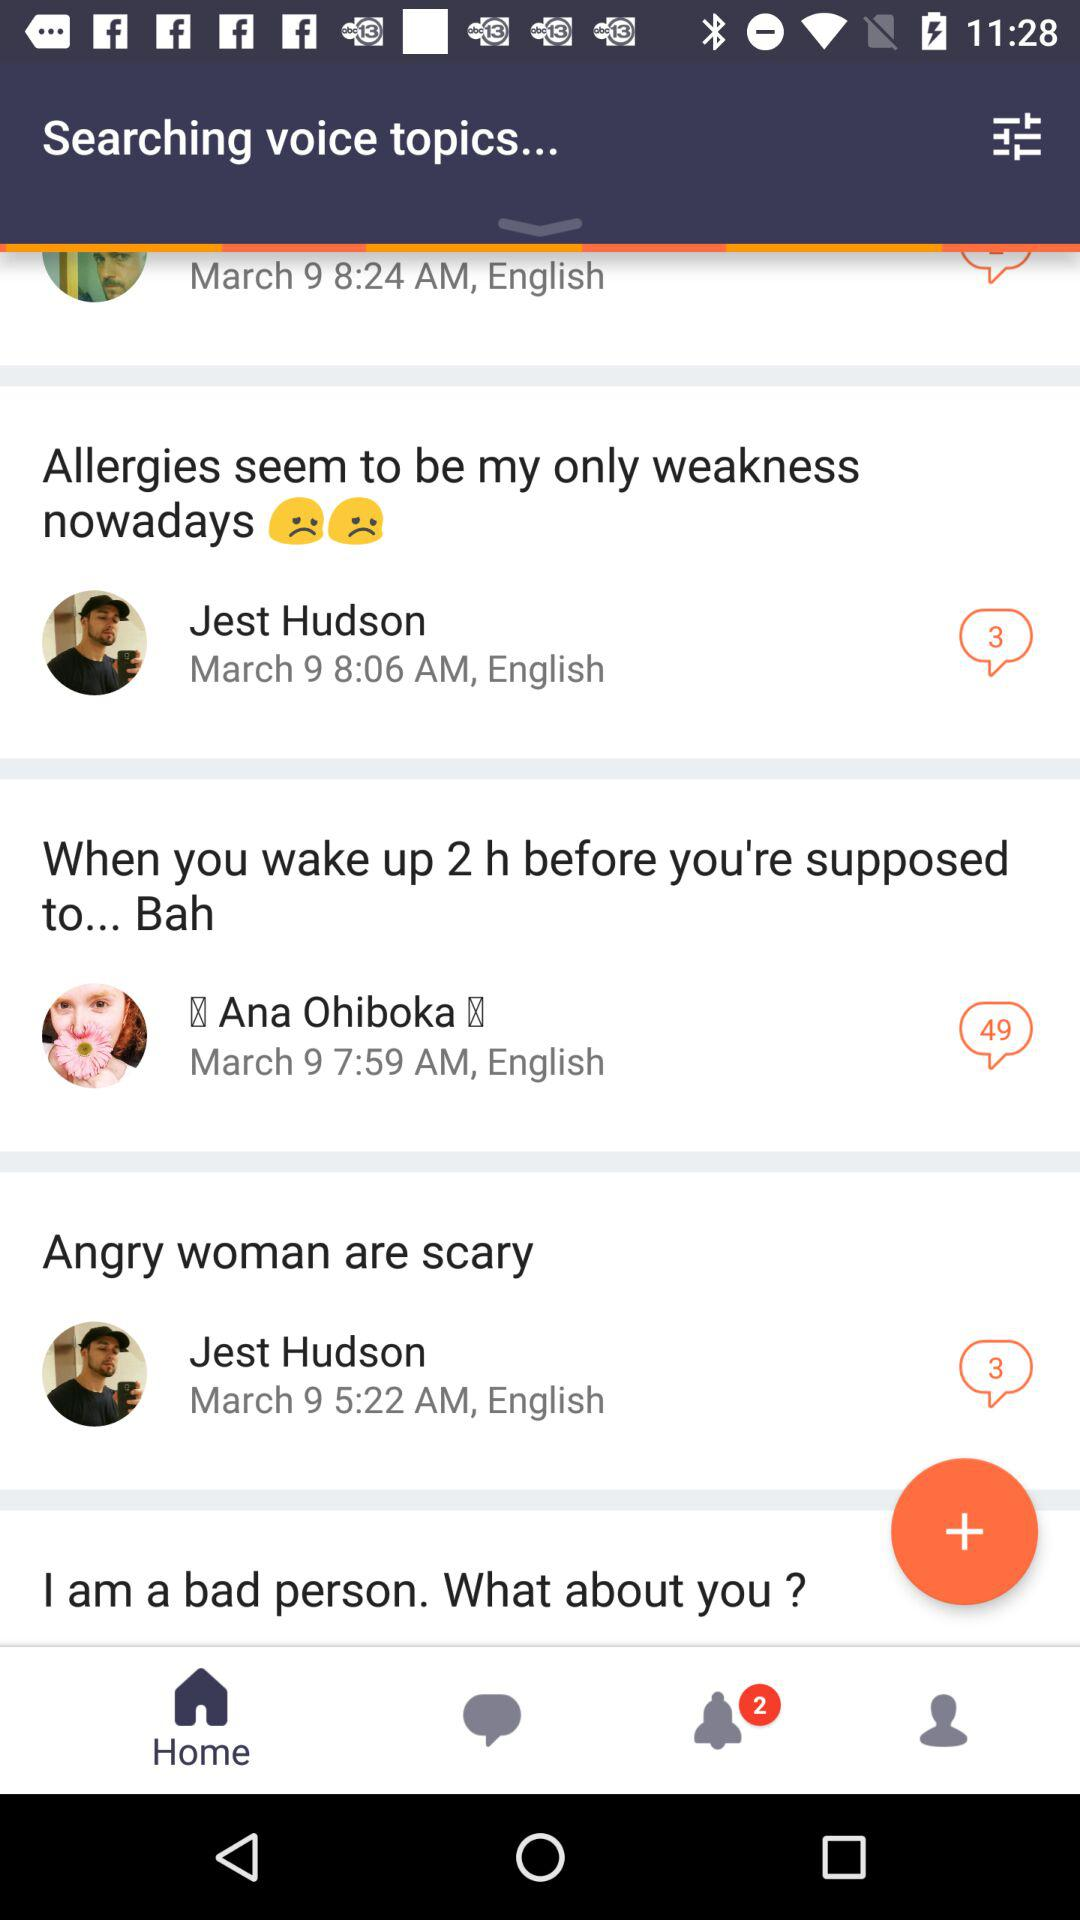What is the number of new messages for Ana Ohiboka? The number of new messages is 49. 